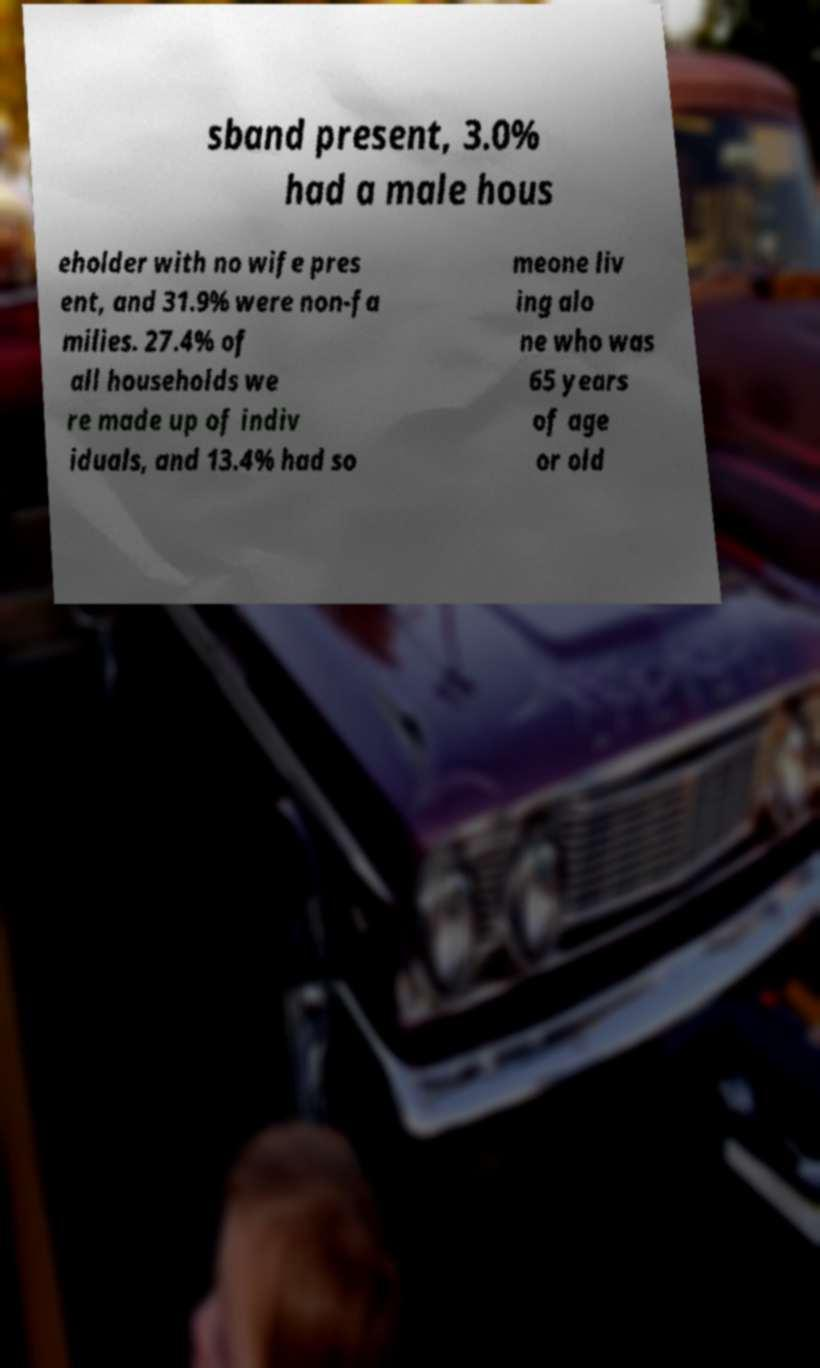For documentation purposes, I need the text within this image transcribed. Could you provide that? sband present, 3.0% had a male hous eholder with no wife pres ent, and 31.9% were non-fa milies. 27.4% of all households we re made up of indiv iduals, and 13.4% had so meone liv ing alo ne who was 65 years of age or old 